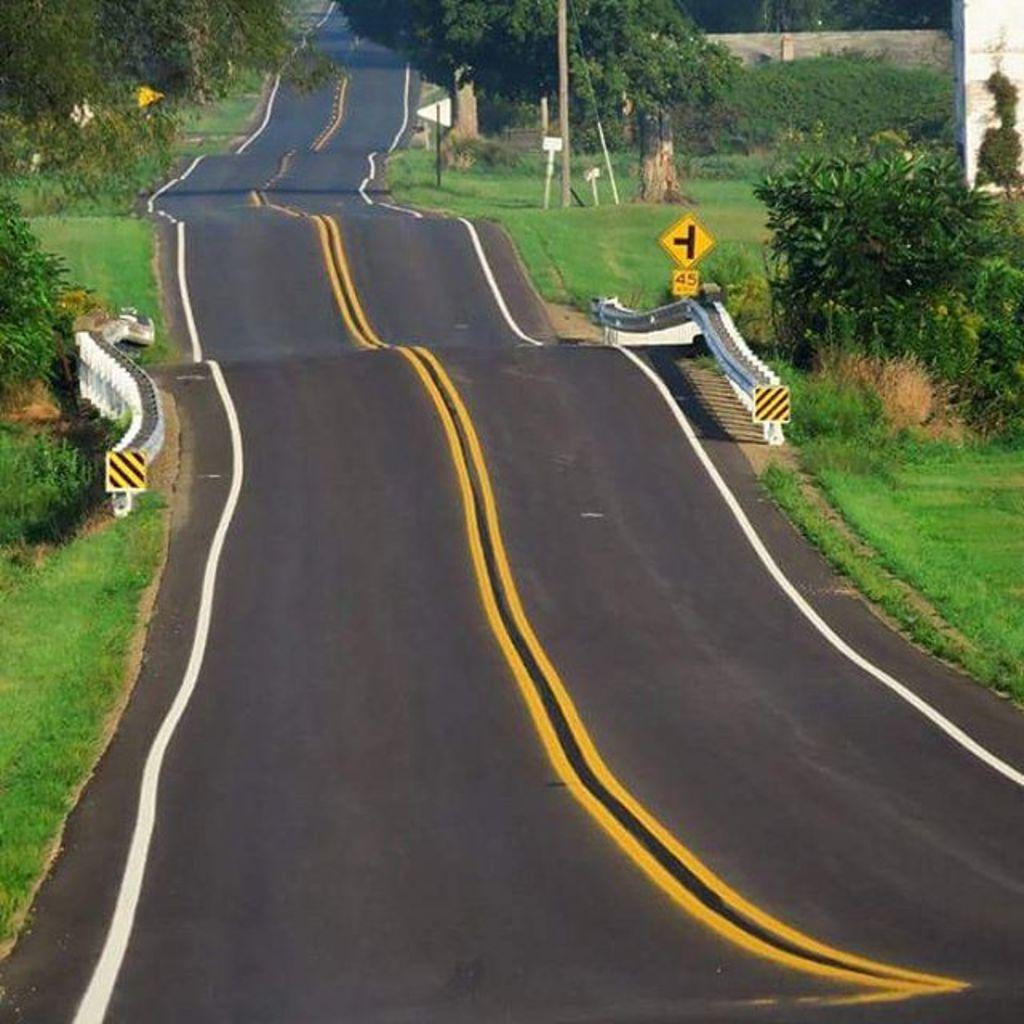Could you give a brief overview of what you see in this image? In the center of the image there is a road. On both right and left side of the image there is grass on the surface and we can see sign boards. In the background there are trees. 